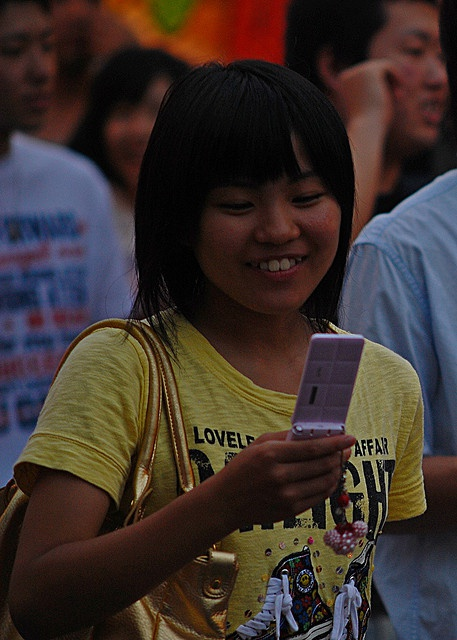Describe the objects in this image and their specific colors. I can see people in black, olive, maroon, and gray tones, people in black, purple, gray, and navy tones, people in black, gray, and darkblue tones, people in black, maroon, and brown tones, and handbag in black, maroon, olive, and gray tones in this image. 